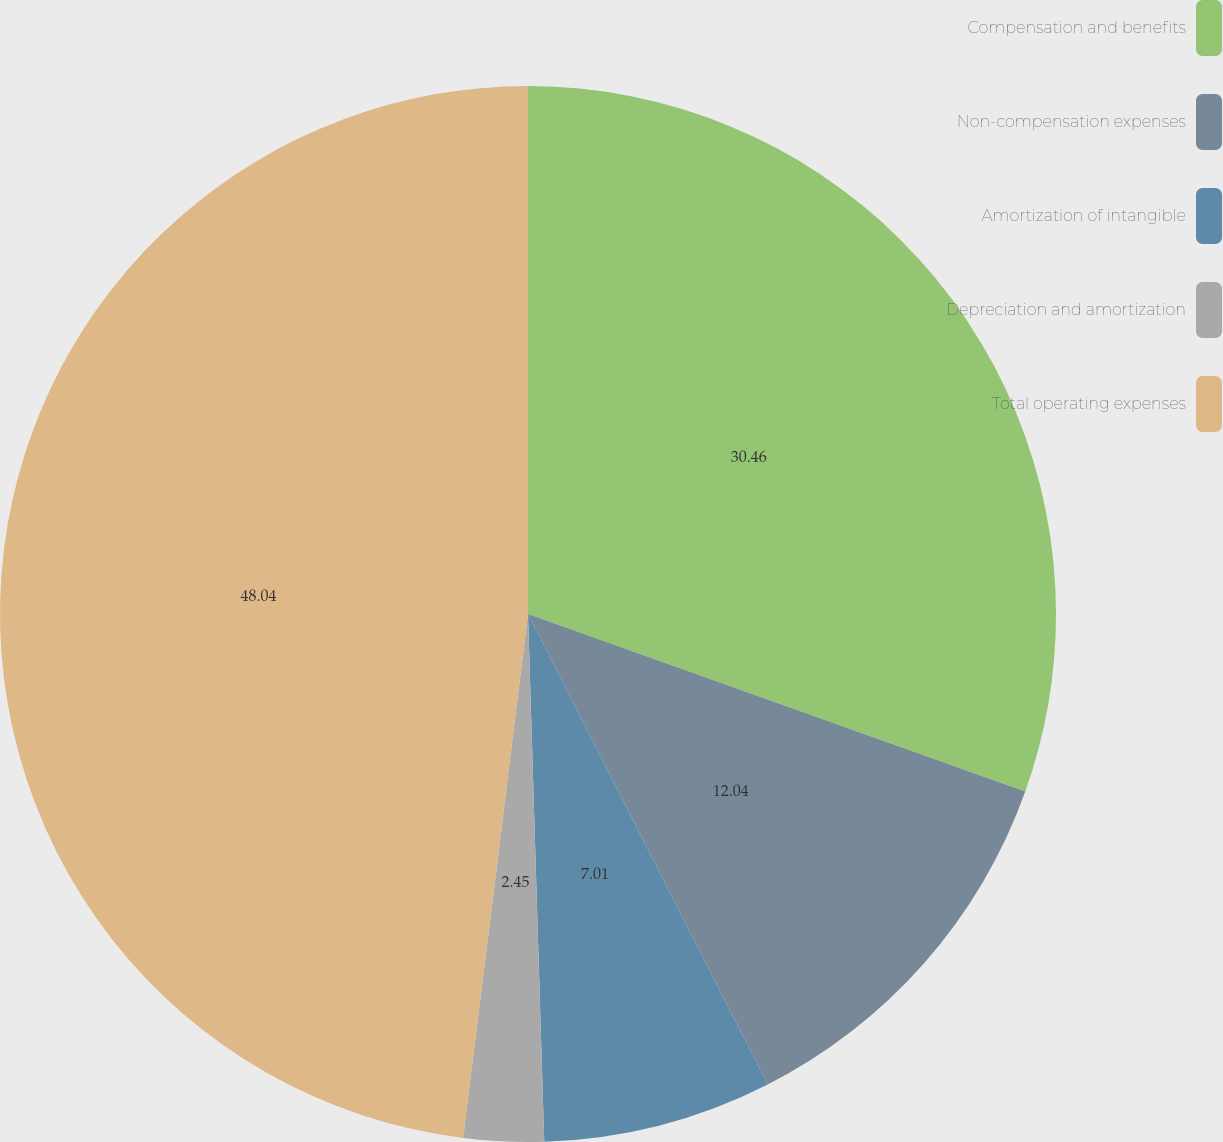Convert chart. <chart><loc_0><loc_0><loc_500><loc_500><pie_chart><fcel>Compensation and benefits<fcel>Non-compensation expenses<fcel>Amortization of intangible<fcel>Depreciation and amortization<fcel>Total operating expenses<nl><fcel>30.46%<fcel>12.04%<fcel>7.01%<fcel>2.45%<fcel>48.04%<nl></chart> 